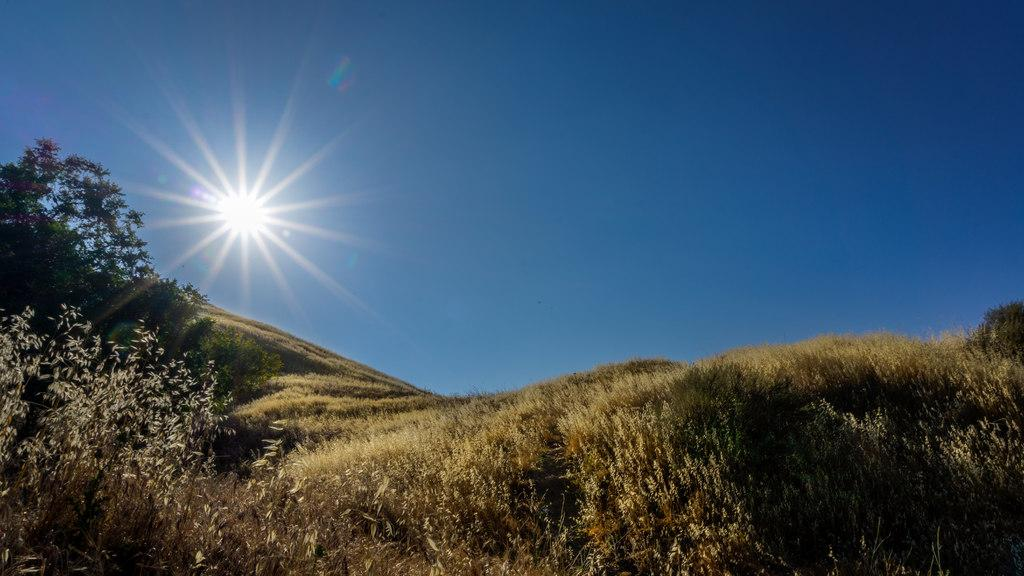What type of vegetation can be seen in the image? There are many trees, plants, and grass in the image. What is visible at the top of the image? The sky is visible at the top of the image. What color is the hair of the person holding the balloon in the image? There is no person holding a balloon in the image; it only features trees, plants, grass, and the sky. 